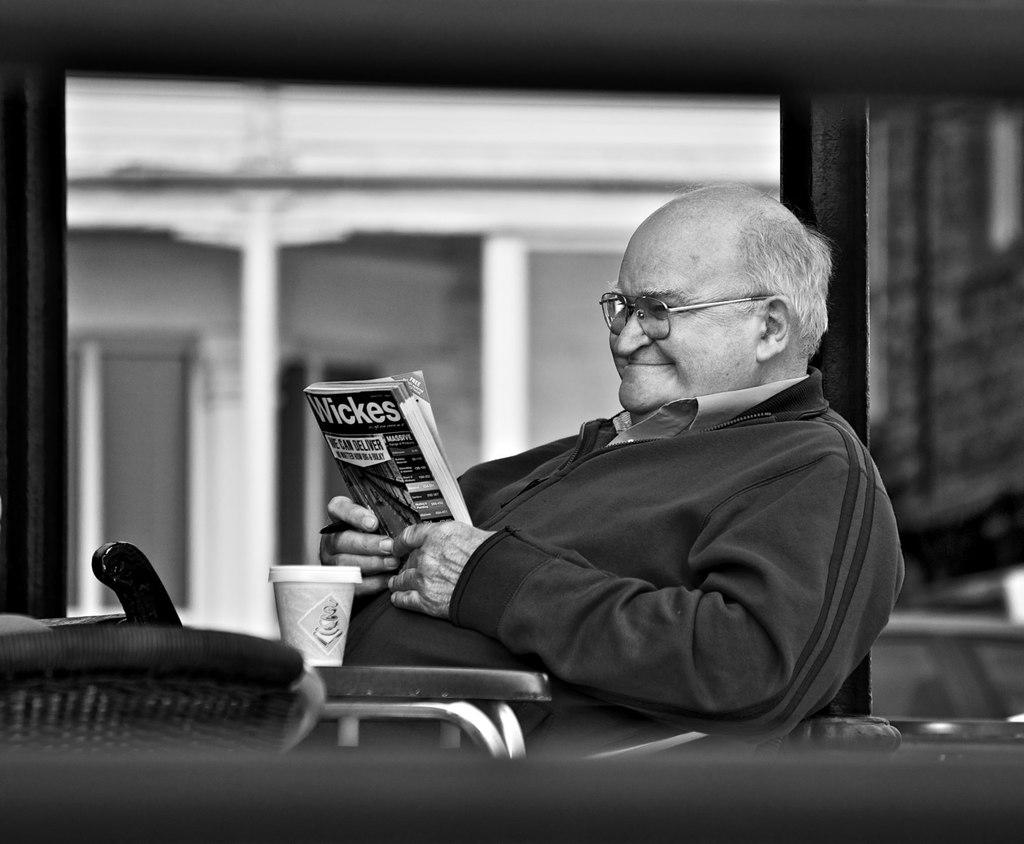Who is present in the image? There is a man in the image. What is the man doing in the image? The man is sitting in the image. What is the man holding in the image? The man is holding a book in the image. What is in front of the man in the image? There is a cup in front of the man in the image. What is the color scheme of the image? The image is in black and white. What type of rhythm can be heard coming from the boat in the image? There is no boat present in the image, so it is not possible to determine what type of rhythm might be heard. 